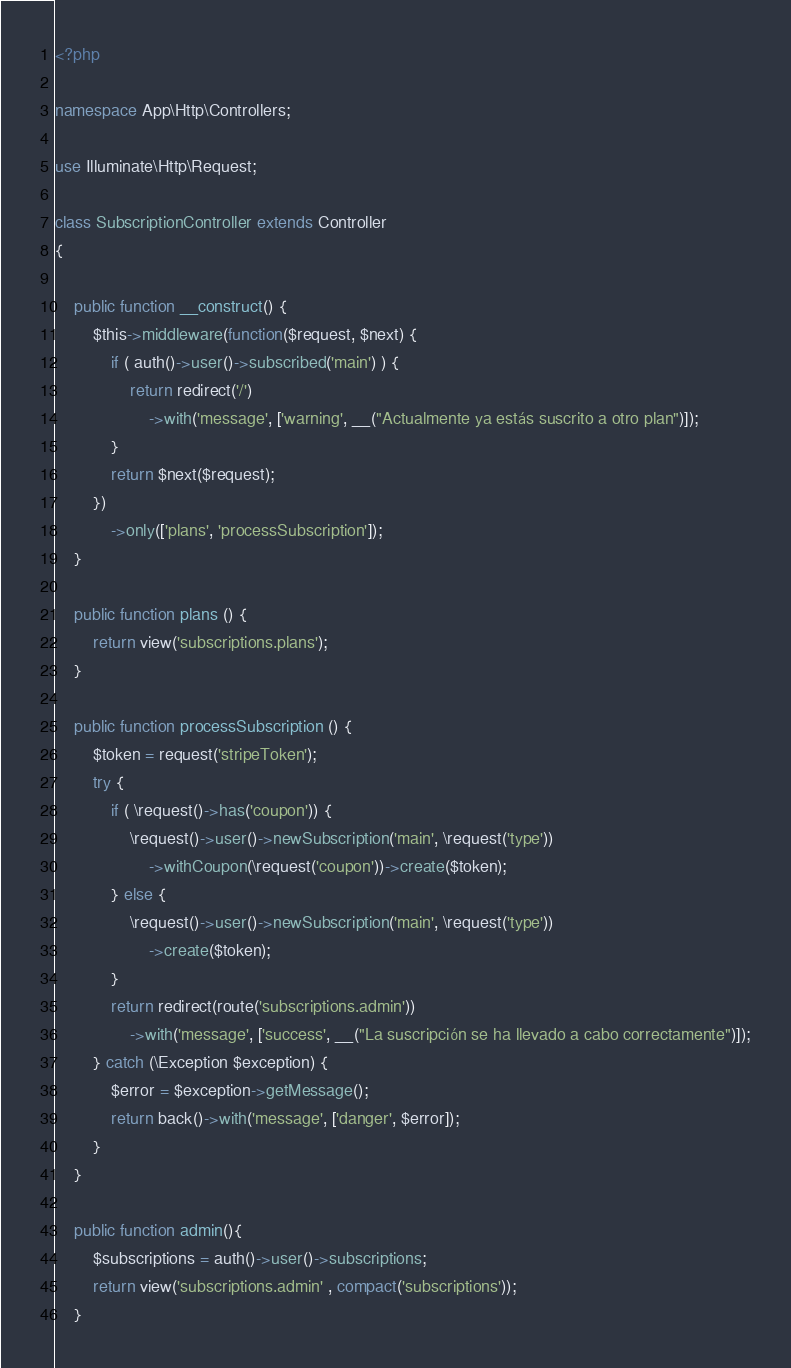<code> <loc_0><loc_0><loc_500><loc_500><_PHP_><?php

namespace App\Http\Controllers;

use Illuminate\Http\Request;

class SubscriptionController extends Controller
{

    public function __construct() {
        $this->middleware(function($request, $next) {
            if ( auth()->user()->subscribed('main') ) {
                return redirect('/')
                    ->with('message', ['warning', __("Actualmente ya estás suscrito a otro plan")]);
            }
            return $next($request);
        })
            ->only(['plans', 'processSubscription']);
    }

    public function plans () {
        return view('subscriptions.plans');
    }

    public function processSubscription () {
        $token = request('stripeToken');
        try {
            if ( \request()->has('coupon')) {
                \request()->user()->newSubscription('main', \request('type'))
                    ->withCoupon(\request('coupon'))->create($token);
            } else {
                \request()->user()->newSubscription('main', \request('type'))
                    ->create($token);
            }
            return redirect(route('subscriptions.admin'))
                ->with('message', ['success', __("La suscripción se ha llevado a cabo correctamente")]);
        } catch (\Exception $exception) {
            $error = $exception->getMessage();
            return back()->with('message', ['danger', $error]);
        }
    }

    public function admin(){
        $subscriptions = auth()->user()->subscriptions;
        return view('subscriptions.admin' , compact('subscriptions'));
    }
</code> 